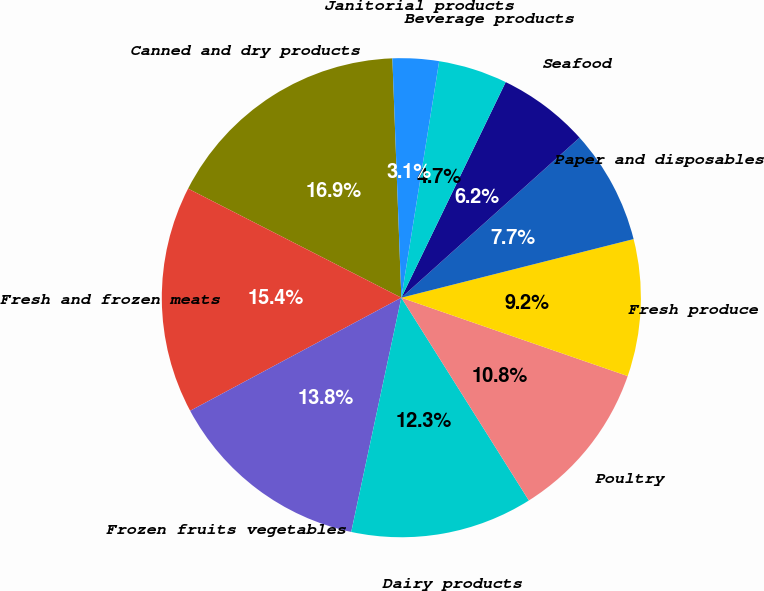<chart> <loc_0><loc_0><loc_500><loc_500><pie_chart><fcel>Canned and dry products<fcel>Fresh and frozen meats<fcel>Frozen fruits vegetables<fcel>Dairy products<fcel>Poultry<fcel>Fresh produce<fcel>Paper and disposables<fcel>Seafood<fcel>Beverage products<fcel>Janitorial products<nl><fcel>16.88%<fcel>15.35%<fcel>13.82%<fcel>12.29%<fcel>10.76%<fcel>9.24%<fcel>7.71%<fcel>6.18%<fcel>4.65%<fcel>3.12%<nl></chart> 